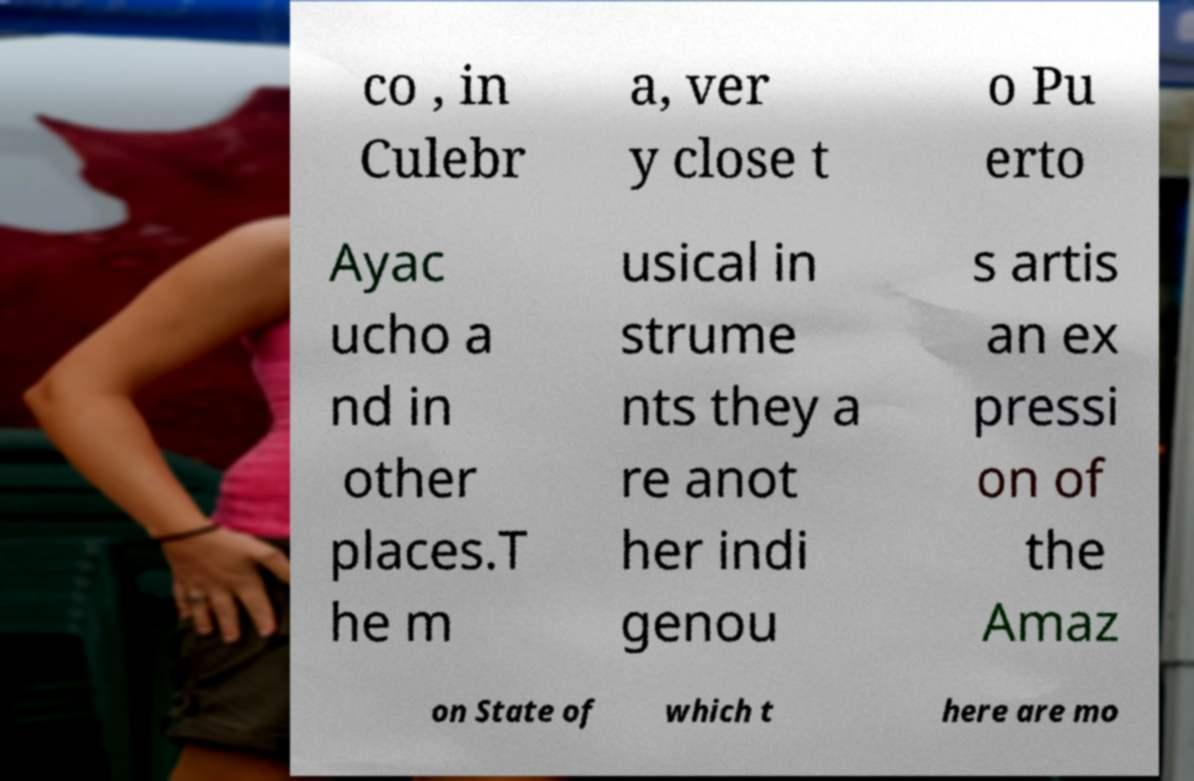There's text embedded in this image that I need extracted. Can you transcribe it verbatim? co , in Culebr a, ver y close t o Pu erto Ayac ucho a nd in other places.T he m usical in strume nts they a re anot her indi genou s artis an ex pressi on of the Amaz on State of which t here are mo 